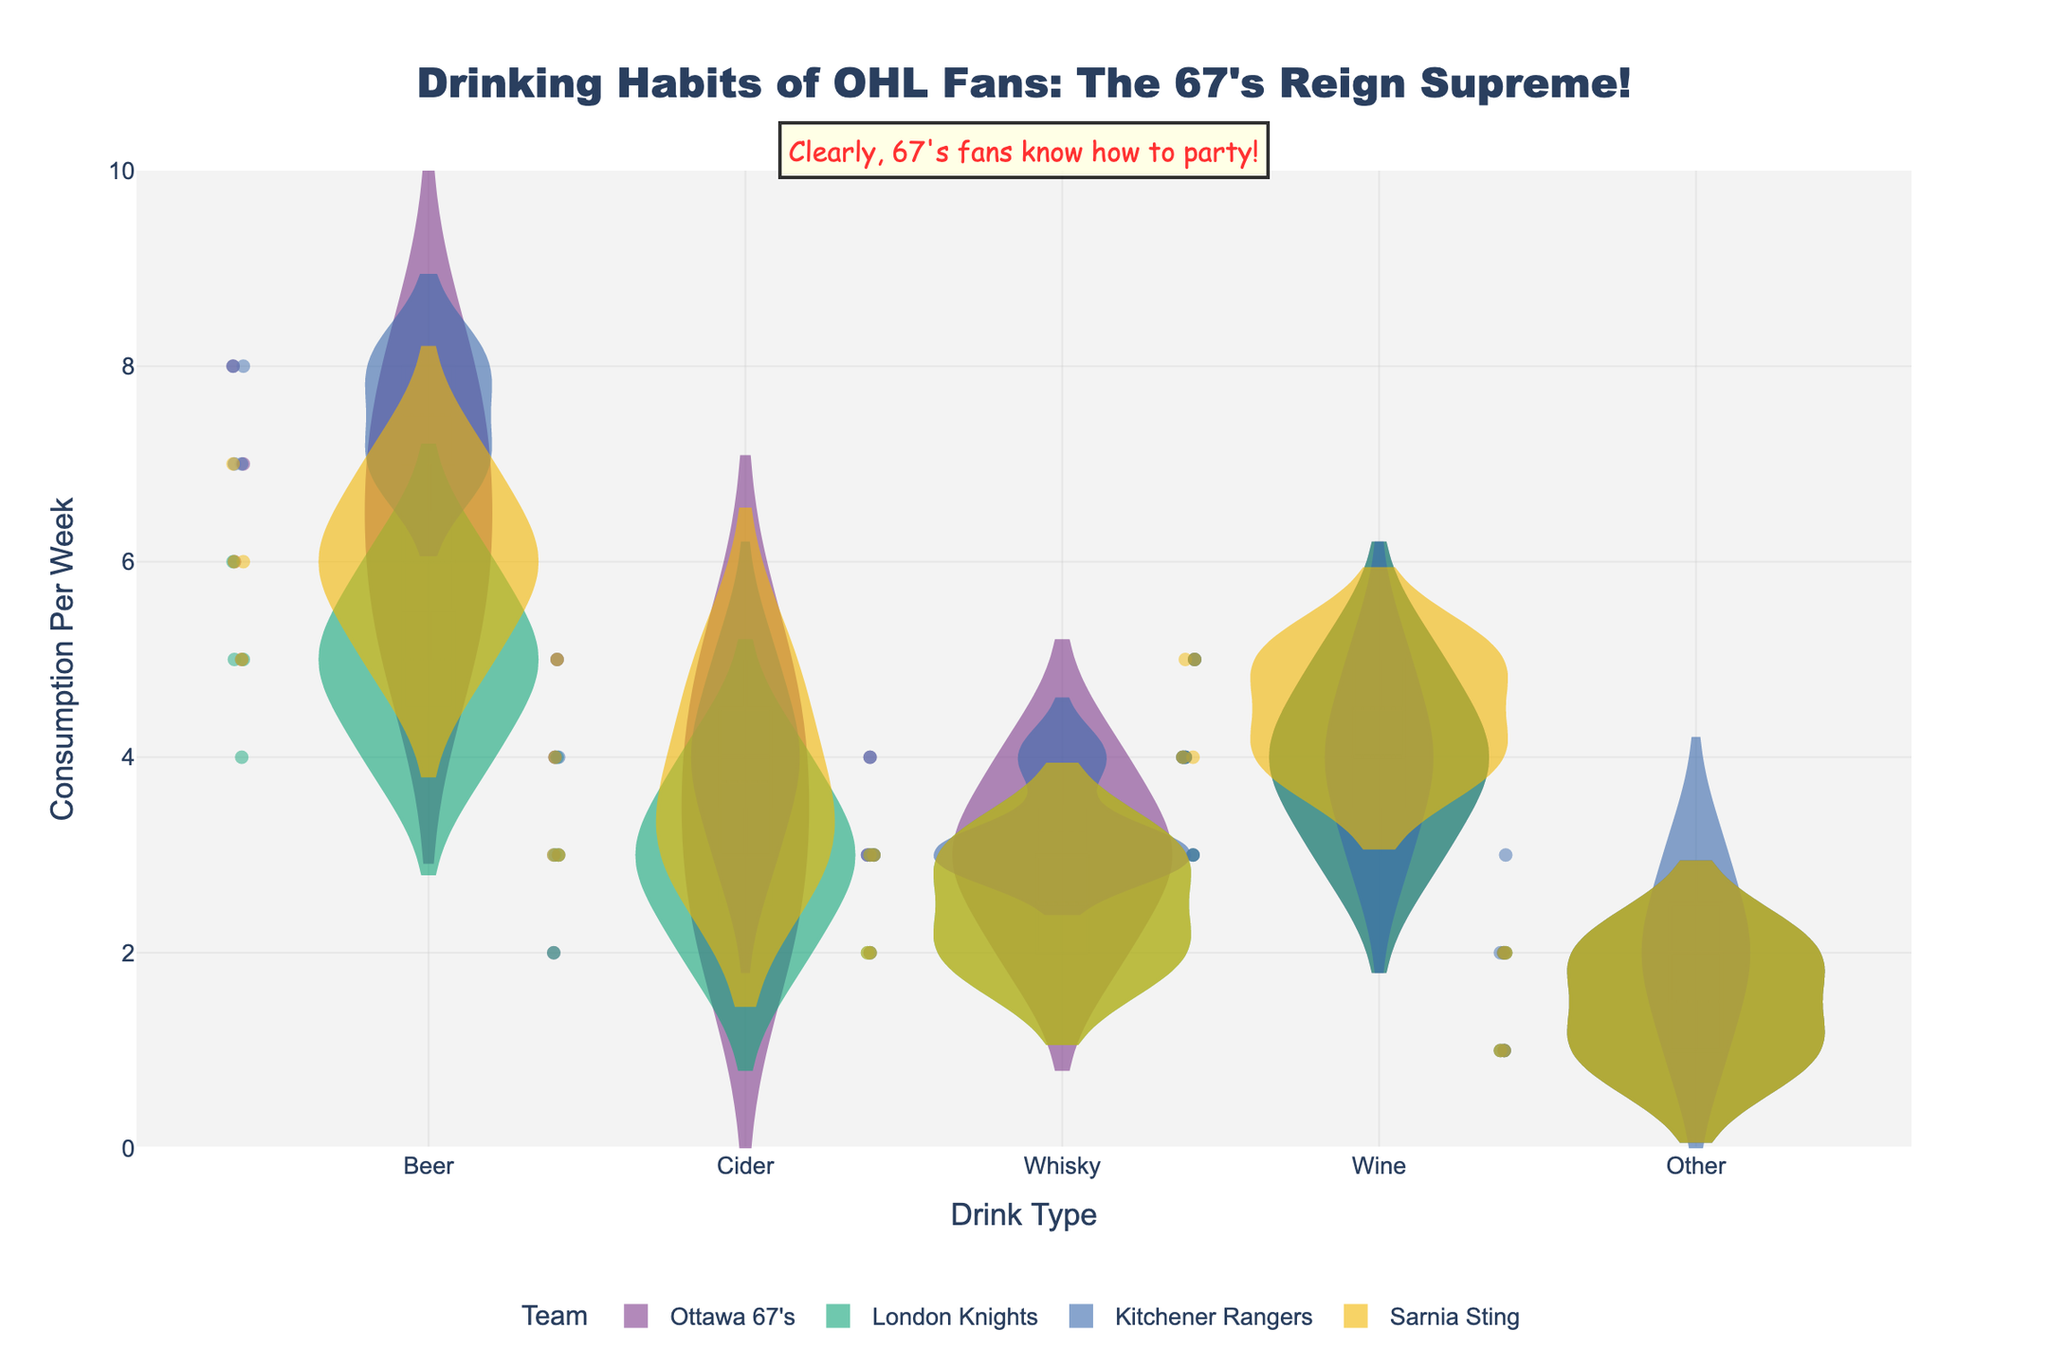Who consumes the most beer per week? The violin plot shows that Kitchener Rangers fans have a higher median beer consumption compared to other teams, indicated by the position of the horizontal line in the box plot within the violin.
Answer: Kitchener Rangers fans How does the wine consumption of Ottawa 67's fans compare to Sarnia Sting fans? Comparing the violin plots for wine consumption, the median (middle line in the box) for both Ottawa 67's and Sarnia Sting fans is quite similar, around 4. Additionally, the spread and general distribution are also similar, indicating comparable consumption.
Answer: Similar What is the highest cider consumption per week for any team? By looking at the individual points plotted on the violin chart for cider, the highest point reaches 5.
Answer: 5 Which team has the lowest average whisky consumption per week? The team with the lowest median line in the whisky section of the violin plots would have the lowest average. Ottawa 67's, London Knights, and Sarnia Sting have similar low median lines, while Kitchener Rangers are slightly higher. Upon closer inspection, London Knights' interquartile range also overlaps with lower values, indicating the lowest average.
Answer: London Knights What is the total range of beer consumption for Ottawa 67's fans? The range is determined by the minimum and maximum values. In the beer section for Ottawa 67's on the violin plot, the whiskers on the box plot within the violin reach 5 and 8. The range is 8 - 5 = 3.
Answer: 3 Which team has the highest variability in wine consumption? Variability can be seen in the shape and width of the violin plot. For wine, Kitchener Rangers have a wider shape, indicating more spread in the data and thus higher variability.
Answer: Kitchener Rangers How does the distribution of 'Other' drinks consumption for Ottawa 67's compare to other teams? For ‘Other’ drinks, Ottawa 67's fans show a narrower violin shape concentrated around lower values (1-2), while other teams like Kitchener Rangers have a slightly more spread out distribution.
Answer: Narrower and lower range What’s the median cider consumption for London Knights fans? The median value is indicated by the central line in the box plot within the violin. For London Knights' cider consumption, this line is at 3.
Answer: 3 